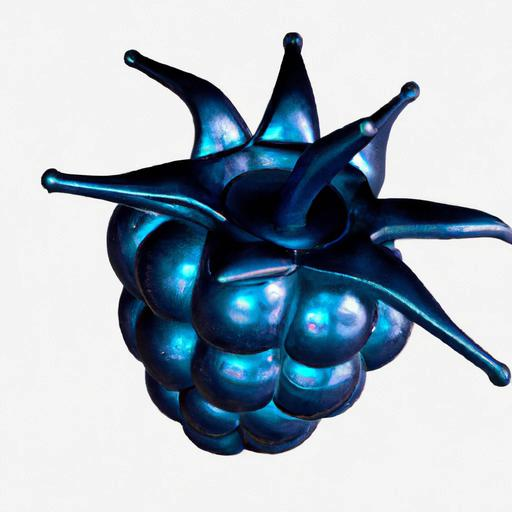What artistic style does this object represent? The object exhibits characteristics of contemporary art with a touch of surrealism. Its exaggerated form and lustrous surface could relate to modern interpretations of organic shapes, making it an interesting statement piece for those who appreciate avant-garde art. 